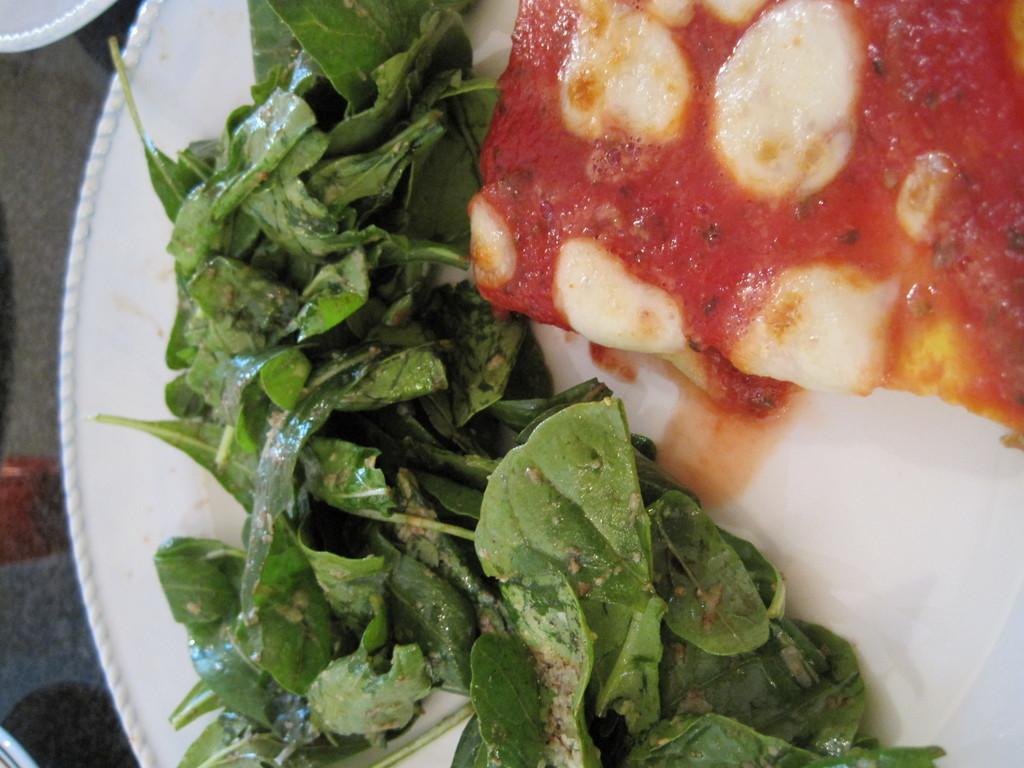What is on the plate that is visible in the image? The plate contains food in the image. What else can be seen in the image besides the plate? Leaves are visible in the image. What type of treatment is being administered to the plate in the image? There is no treatment being administered to the plate in the image; it simply contains food. 